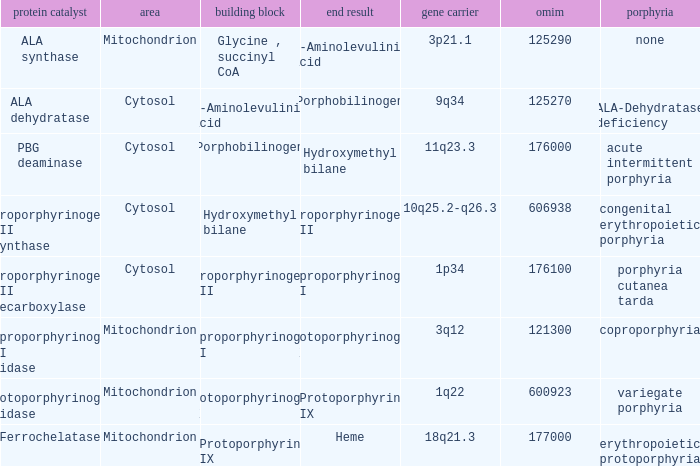Which substrate has an OMIM of 176000? Porphobilinogen. 